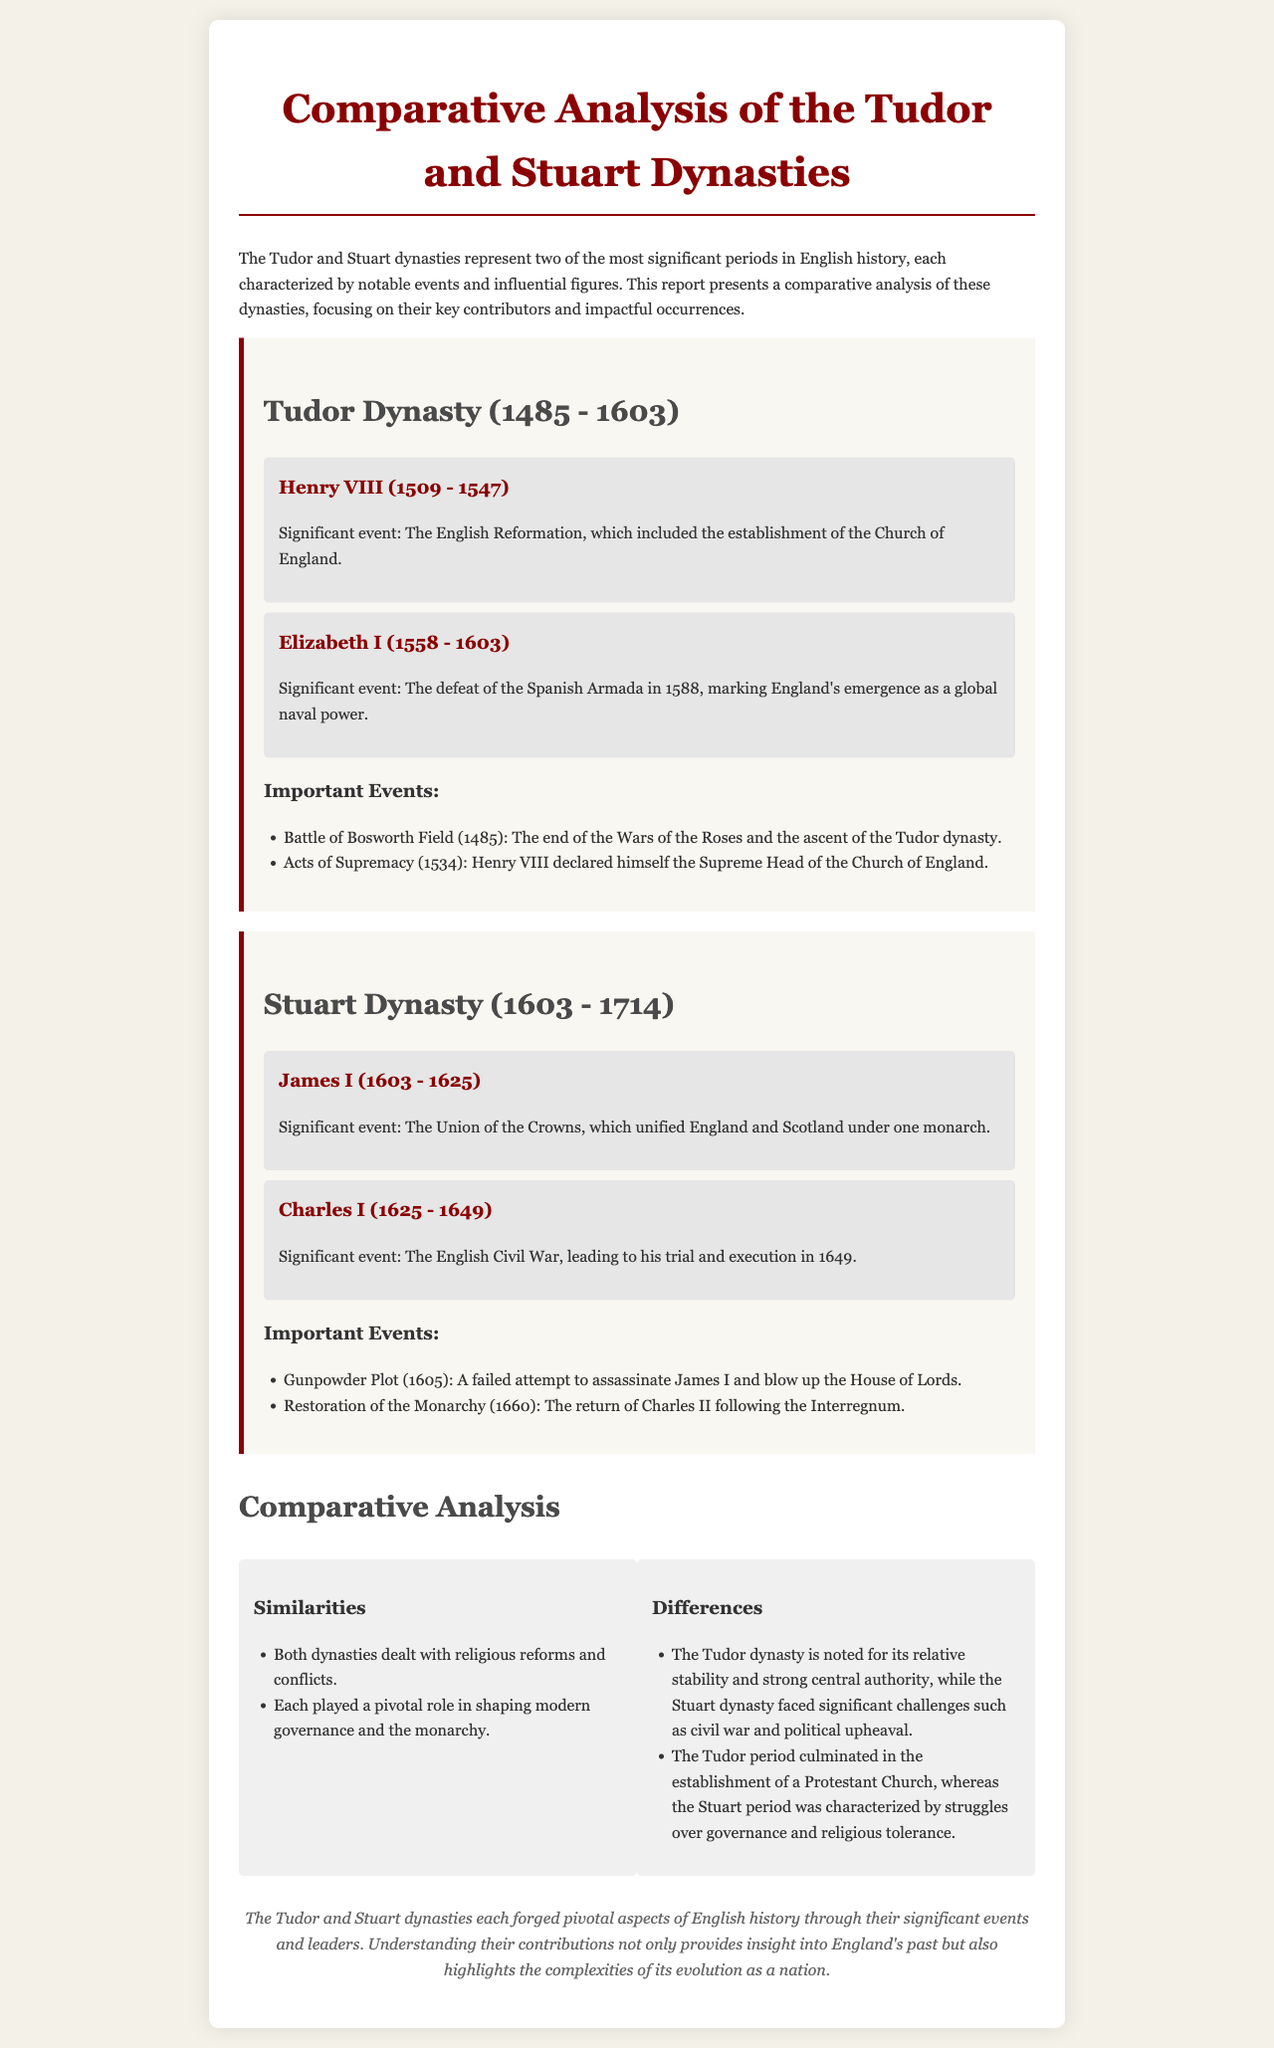What years did the Tudor Dynasty span? The document states that the Tudor Dynasty lasted from 1485 to 1603.
Answer: 1485 - 1603 Who was the monarch during the English Civil War? According to the report, Charles I was the monarch during the English Civil War.
Answer: Charles I What significant event occurred in 1588 during the Tudor Dynasty? The document mentions the defeat of the Spanish Armada as a significant event in 1588.
Answer: Defeat of the Spanish Armada What was the main religious reform associated with Henry VIII? The establishment of the Church of England is noted as the significant event related to Henry VIII.
Answer: Establishment of the Church of England Which two dynasties are compared in the report? The document specifically compares the Tudor and Stuart dynasties.
Answer: Tudor and Stuart What was a major challenge faced by the Stuart dynasty? The report highlights civil war and political upheaval as major challenges faced by the Stuart dynasty.
Answer: Civil war What did the Gunpowder Plot fail to achieve? The document states that it was a failed attempt to assassinate James I and blow up the House of Lords.
Answer: Assassinate James I What is a key similarity between the two dynasties? Both dynasties dealt with religious reforms and conflicts, according to the comparative analysis.
Answer: Religious reforms and conflicts In what year did the Restoration of the Monarchy occur? The report indicates that the Restoration of the Monarchy took place in 1660.
Answer: 1660 